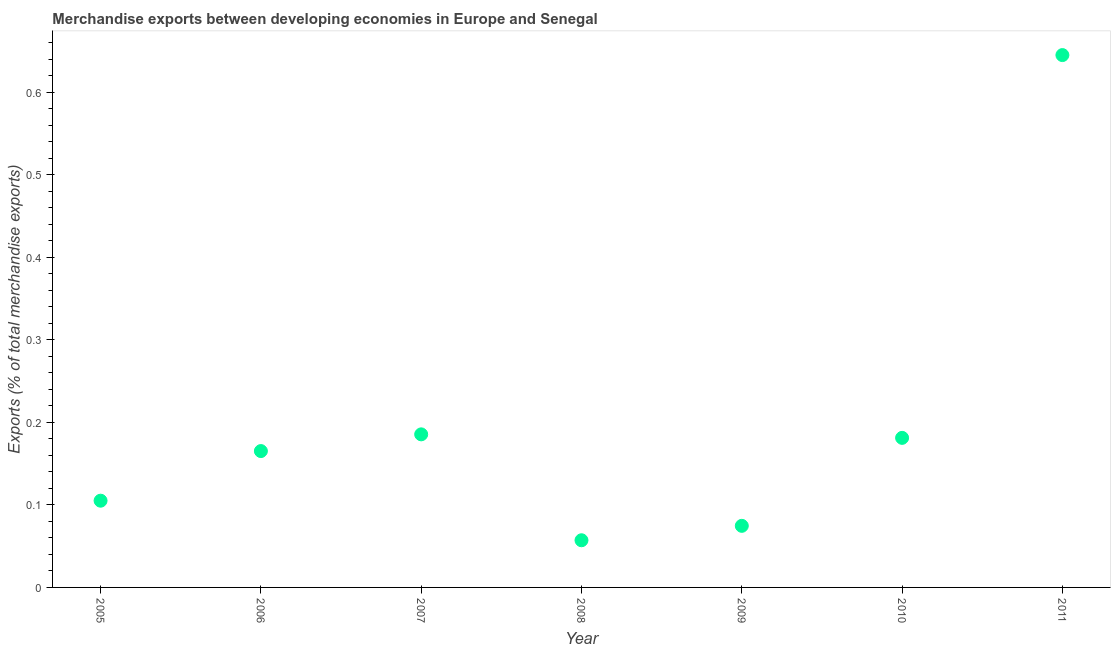What is the merchandise exports in 2006?
Offer a terse response. 0.17. Across all years, what is the maximum merchandise exports?
Keep it short and to the point. 0.64. Across all years, what is the minimum merchandise exports?
Your response must be concise. 0.06. What is the sum of the merchandise exports?
Your answer should be very brief. 1.41. What is the difference between the merchandise exports in 2005 and 2007?
Keep it short and to the point. -0.08. What is the average merchandise exports per year?
Your answer should be compact. 0.2. What is the median merchandise exports?
Make the answer very short. 0.17. Do a majority of the years between 2005 and 2010 (inclusive) have merchandise exports greater than 0.56 %?
Offer a terse response. No. What is the ratio of the merchandise exports in 2006 to that in 2008?
Ensure brevity in your answer.  2.89. Is the merchandise exports in 2006 less than that in 2010?
Offer a terse response. Yes. Is the difference between the merchandise exports in 2008 and 2009 greater than the difference between any two years?
Make the answer very short. No. What is the difference between the highest and the second highest merchandise exports?
Provide a short and direct response. 0.46. What is the difference between the highest and the lowest merchandise exports?
Make the answer very short. 0.59. In how many years, is the merchandise exports greater than the average merchandise exports taken over all years?
Offer a terse response. 1. What is the difference between two consecutive major ticks on the Y-axis?
Your answer should be very brief. 0.1. Are the values on the major ticks of Y-axis written in scientific E-notation?
Your answer should be very brief. No. Does the graph contain any zero values?
Provide a short and direct response. No. What is the title of the graph?
Give a very brief answer. Merchandise exports between developing economies in Europe and Senegal. What is the label or title of the X-axis?
Your answer should be compact. Year. What is the label or title of the Y-axis?
Provide a short and direct response. Exports (% of total merchandise exports). What is the Exports (% of total merchandise exports) in 2005?
Offer a very short reply. 0.11. What is the Exports (% of total merchandise exports) in 2006?
Provide a short and direct response. 0.17. What is the Exports (% of total merchandise exports) in 2007?
Ensure brevity in your answer.  0.19. What is the Exports (% of total merchandise exports) in 2008?
Offer a very short reply. 0.06. What is the Exports (% of total merchandise exports) in 2009?
Ensure brevity in your answer.  0.07. What is the Exports (% of total merchandise exports) in 2010?
Give a very brief answer. 0.18. What is the Exports (% of total merchandise exports) in 2011?
Your response must be concise. 0.64. What is the difference between the Exports (% of total merchandise exports) in 2005 and 2006?
Give a very brief answer. -0.06. What is the difference between the Exports (% of total merchandise exports) in 2005 and 2007?
Give a very brief answer. -0.08. What is the difference between the Exports (% of total merchandise exports) in 2005 and 2008?
Your answer should be compact. 0.05. What is the difference between the Exports (% of total merchandise exports) in 2005 and 2009?
Offer a terse response. 0.03. What is the difference between the Exports (% of total merchandise exports) in 2005 and 2010?
Provide a succinct answer. -0.08. What is the difference between the Exports (% of total merchandise exports) in 2005 and 2011?
Give a very brief answer. -0.54. What is the difference between the Exports (% of total merchandise exports) in 2006 and 2007?
Your answer should be compact. -0.02. What is the difference between the Exports (% of total merchandise exports) in 2006 and 2008?
Your answer should be compact. 0.11. What is the difference between the Exports (% of total merchandise exports) in 2006 and 2009?
Keep it short and to the point. 0.09. What is the difference between the Exports (% of total merchandise exports) in 2006 and 2010?
Keep it short and to the point. -0.02. What is the difference between the Exports (% of total merchandise exports) in 2006 and 2011?
Provide a short and direct response. -0.48. What is the difference between the Exports (% of total merchandise exports) in 2007 and 2008?
Give a very brief answer. 0.13. What is the difference between the Exports (% of total merchandise exports) in 2007 and 2009?
Ensure brevity in your answer.  0.11. What is the difference between the Exports (% of total merchandise exports) in 2007 and 2010?
Your response must be concise. 0. What is the difference between the Exports (% of total merchandise exports) in 2007 and 2011?
Offer a terse response. -0.46. What is the difference between the Exports (% of total merchandise exports) in 2008 and 2009?
Provide a succinct answer. -0.02. What is the difference between the Exports (% of total merchandise exports) in 2008 and 2010?
Your answer should be very brief. -0.12. What is the difference between the Exports (% of total merchandise exports) in 2008 and 2011?
Provide a short and direct response. -0.59. What is the difference between the Exports (% of total merchandise exports) in 2009 and 2010?
Your answer should be compact. -0.11. What is the difference between the Exports (% of total merchandise exports) in 2009 and 2011?
Give a very brief answer. -0.57. What is the difference between the Exports (% of total merchandise exports) in 2010 and 2011?
Keep it short and to the point. -0.46. What is the ratio of the Exports (% of total merchandise exports) in 2005 to that in 2006?
Give a very brief answer. 0.64. What is the ratio of the Exports (% of total merchandise exports) in 2005 to that in 2007?
Ensure brevity in your answer.  0.57. What is the ratio of the Exports (% of total merchandise exports) in 2005 to that in 2008?
Provide a short and direct response. 1.84. What is the ratio of the Exports (% of total merchandise exports) in 2005 to that in 2009?
Your answer should be very brief. 1.41. What is the ratio of the Exports (% of total merchandise exports) in 2005 to that in 2010?
Offer a terse response. 0.58. What is the ratio of the Exports (% of total merchandise exports) in 2005 to that in 2011?
Your answer should be very brief. 0.16. What is the ratio of the Exports (% of total merchandise exports) in 2006 to that in 2007?
Give a very brief answer. 0.89. What is the ratio of the Exports (% of total merchandise exports) in 2006 to that in 2008?
Give a very brief answer. 2.89. What is the ratio of the Exports (% of total merchandise exports) in 2006 to that in 2009?
Keep it short and to the point. 2.21. What is the ratio of the Exports (% of total merchandise exports) in 2006 to that in 2010?
Offer a terse response. 0.91. What is the ratio of the Exports (% of total merchandise exports) in 2006 to that in 2011?
Offer a terse response. 0.26. What is the ratio of the Exports (% of total merchandise exports) in 2007 to that in 2008?
Your answer should be compact. 3.25. What is the ratio of the Exports (% of total merchandise exports) in 2007 to that in 2009?
Provide a short and direct response. 2.48. What is the ratio of the Exports (% of total merchandise exports) in 2007 to that in 2011?
Provide a short and direct response. 0.29. What is the ratio of the Exports (% of total merchandise exports) in 2008 to that in 2009?
Provide a succinct answer. 0.77. What is the ratio of the Exports (% of total merchandise exports) in 2008 to that in 2010?
Provide a succinct answer. 0.32. What is the ratio of the Exports (% of total merchandise exports) in 2008 to that in 2011?
Your answer should be very brief. 0.09. What is the ratio of the Exports (% of total merchandise exports) in 2009 to that in 2010?
Provide a succinct answer. 0.41. What is the ratio of the Exports (% of total merchandise exports) in 2009 to that in 2011?
Provide a short and direct response. 0.12. What is the ratio of the Exports (% of total merchandise exports) in 2010 to that in 2011?
Ensure brevity in your answer.  0.28. 